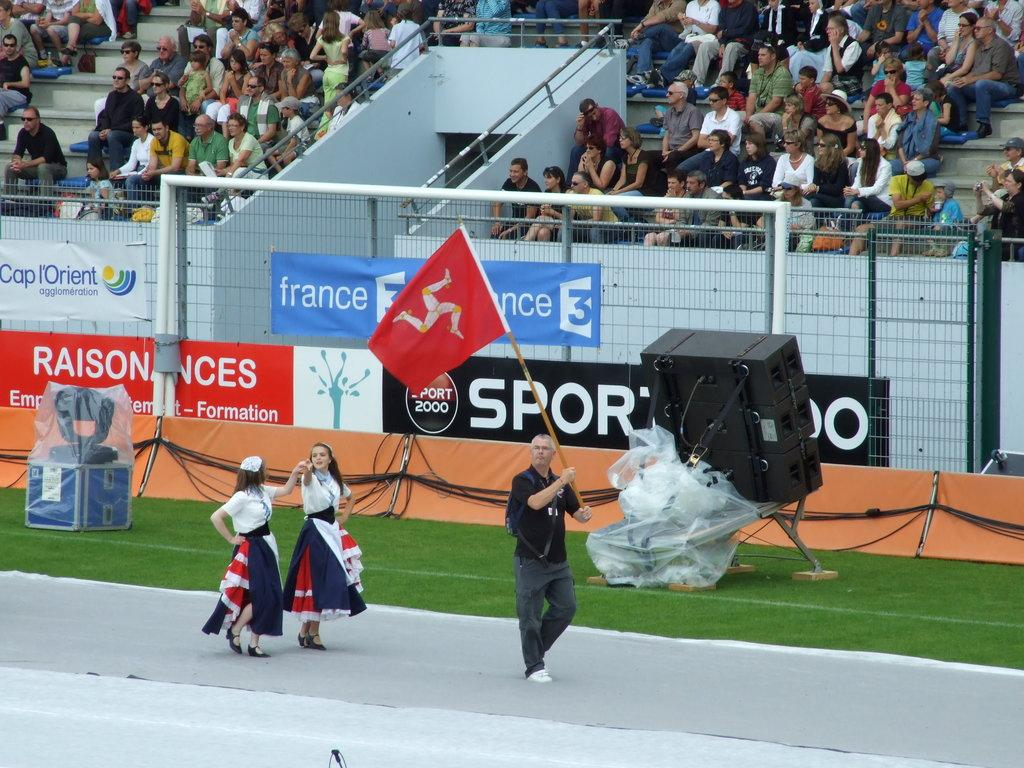<image>
Offer a succinct explanation of the picture presented. A man holding a red flag in stadium in France. 